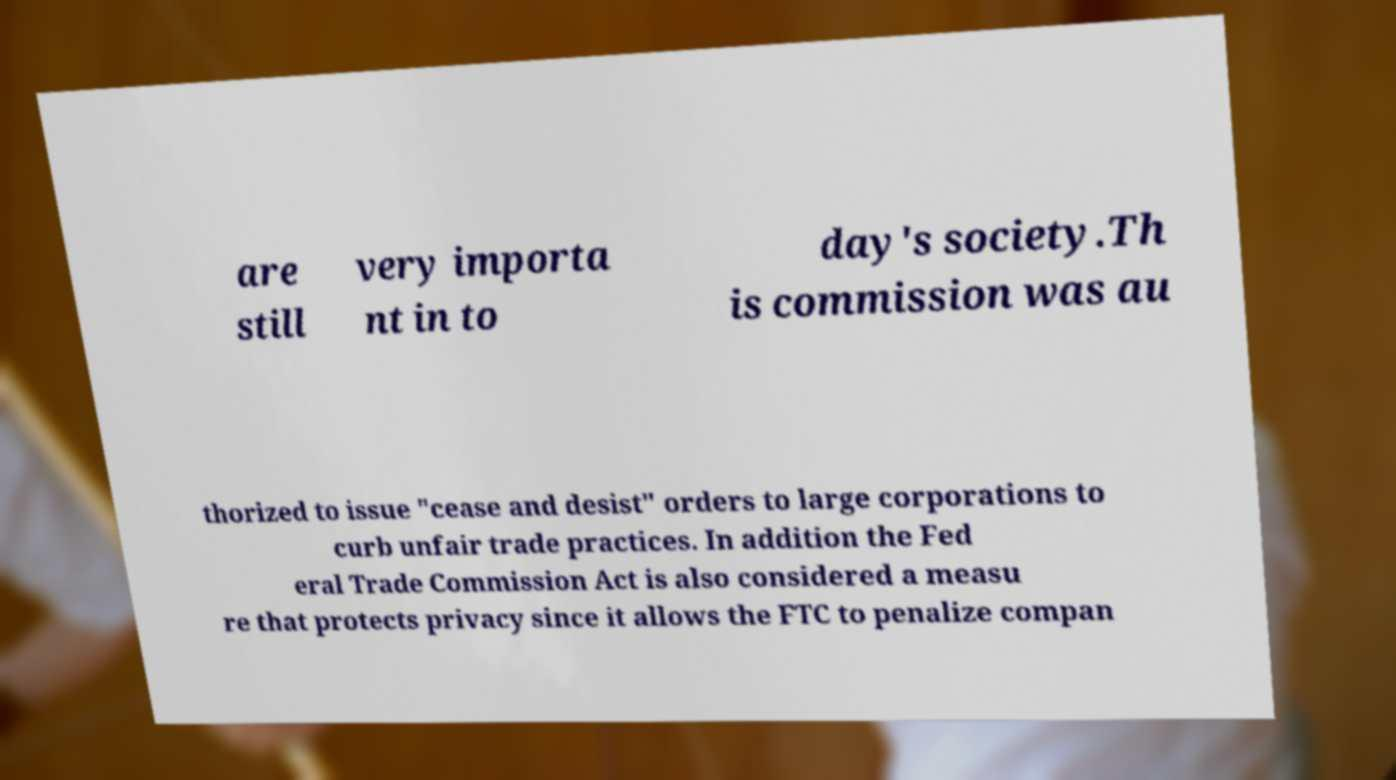Can you accurately transcribe the text from the provided image for me? are still very importa nt in to day's society.Th is commission was au thorized to issue "cease and desist" orders to large corporations to curb unfair trade practices. In addition the Fed eral Trade Commission Act is also considered a measu re that protects privacy since it allows the FTC to penalize compan 